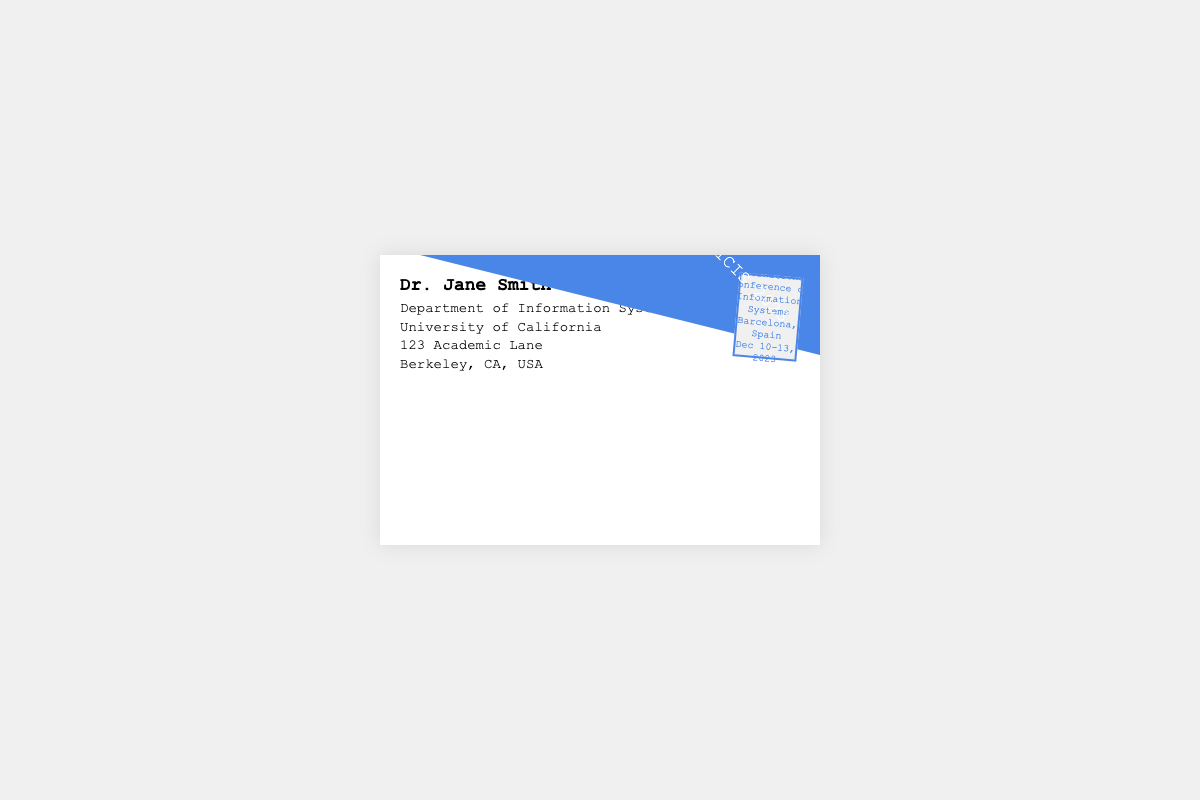What is the recipient's name? The recipient's name is prominently displayed in the envelope.
Answer: Dr. Jane Smith What is the recipient's institution? The institution is specified right below the recipient's name.
Answer: Department of Information Systems What city is the conference being held? The location of the conference is mentioned in the stamp area of the envelope.
Answer: Barcelona What are the conference dates? The dates are provided in the stamp, indicating when the conference will occur.
Answer: Dec 10-13, 2023 What is the title of the conference mentioned? The title is prominently featured in the stamp as well.
Answer: International Conference on Information Systems How many lines are in the recipient's address? The number of lines in the address section gives an idea about its length.
Answer: 2 What color is the envelope design? The main characteristic of the envelope is its color, which is highlighted in the style.
Answer: White What is the background color of the document? The document has a specified background color that is visible behind the envelope.
Answer: Light gray Is there any specific rotation applied to the stamp? The appearance of the stamp is characterized by a distinct visual effect.
Answer: 5 degrees 